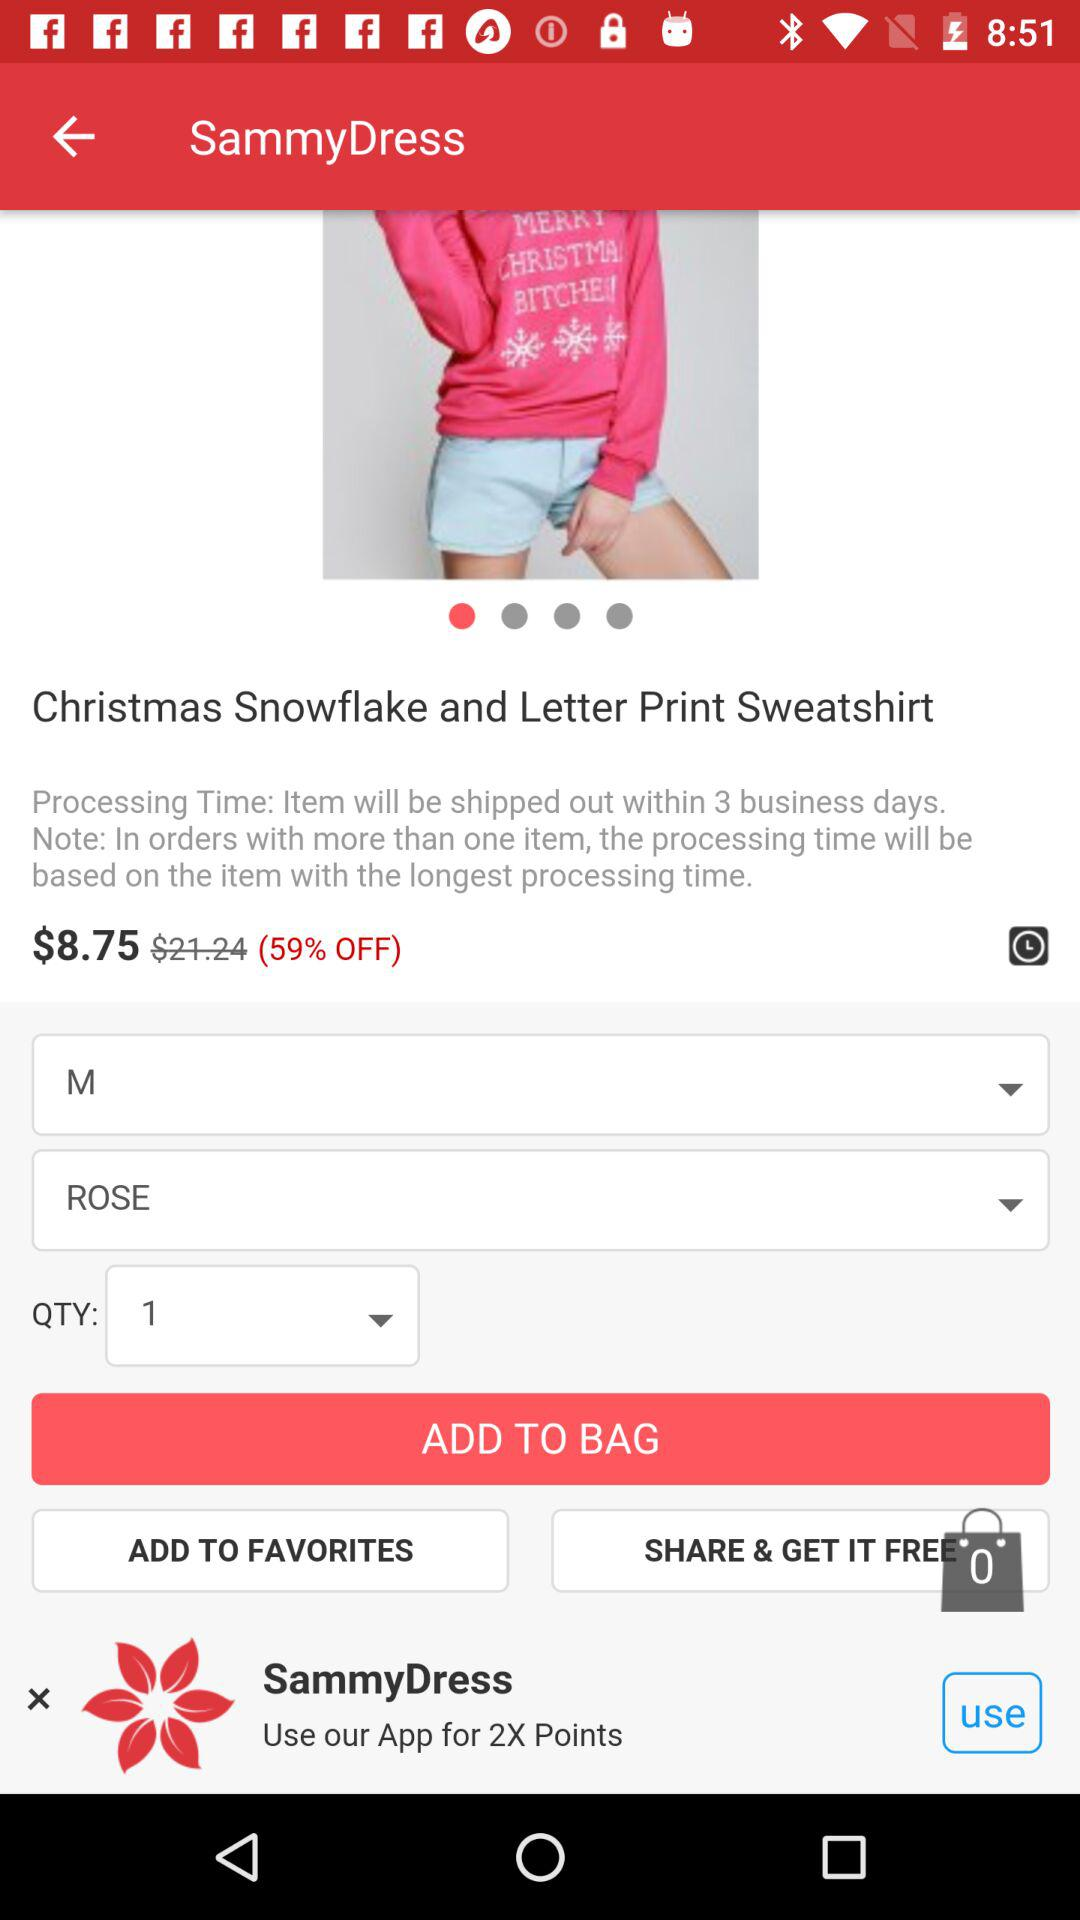What is the price of a sweatshirt? What is the discounted price of the sweatshirt? The discounted price of the sweatshirt is $8.75. 